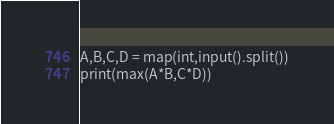<code> <loc_0><loc_0><loc_500><loc_500><_Python_>A,B,C,D = map(int,input().split())
print(max(A*B,C*D))</code> 